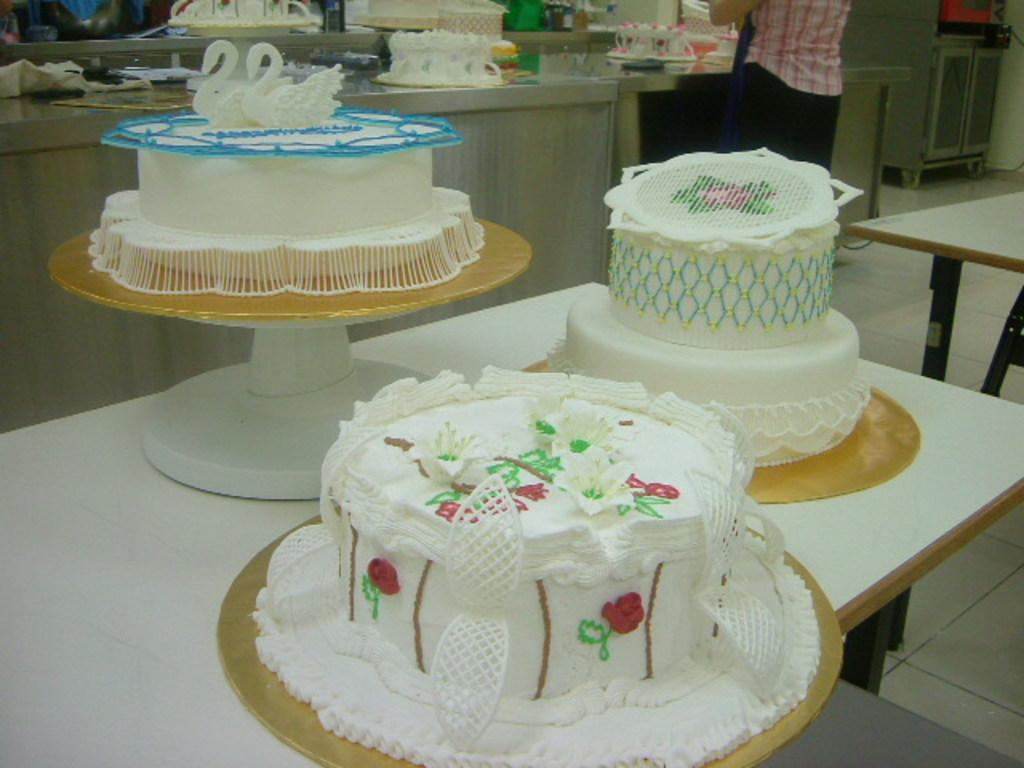What type of dessert can be seen in the image? There are three white cakes in the image. How are the cakes decorated? The cakes are beautifully designed. Where are the cakes located in the image? The cakes are placed on a table. What can be seen in the background of the image? In the background, there are cakes in progress. Where is the cheese stored in the image? There is no cheese present in the image. What type of store can be seen in the background of the image? There is no store visible in the image; it features cakes in progress in the background. 